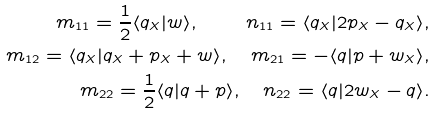<formula> <loc_0><loc_0><loc_500><loc_500>m _ { 1 1 } = \frac { 1 } { 2 } \langle q _ { X } | w \rangle , \quad n _ { 1 1 } = \langle q _ { X } | 2 p _ { X } - q _ { X } \rangle , \\ m _ { 1 2 } = \langle q _ { X } | q _ { X } + p _ { X } + w \rangle , \quad m _ { 2 1 } = - \langle q | p + w _ { X } \rangle , \\ m _ { 2 2 } = \frac { 1 } { 2 } \langle q | q + p \rangle , \quad n _ { 2 2 } = \langle q | 2 w _ { X } - q \rangle .</formula> 